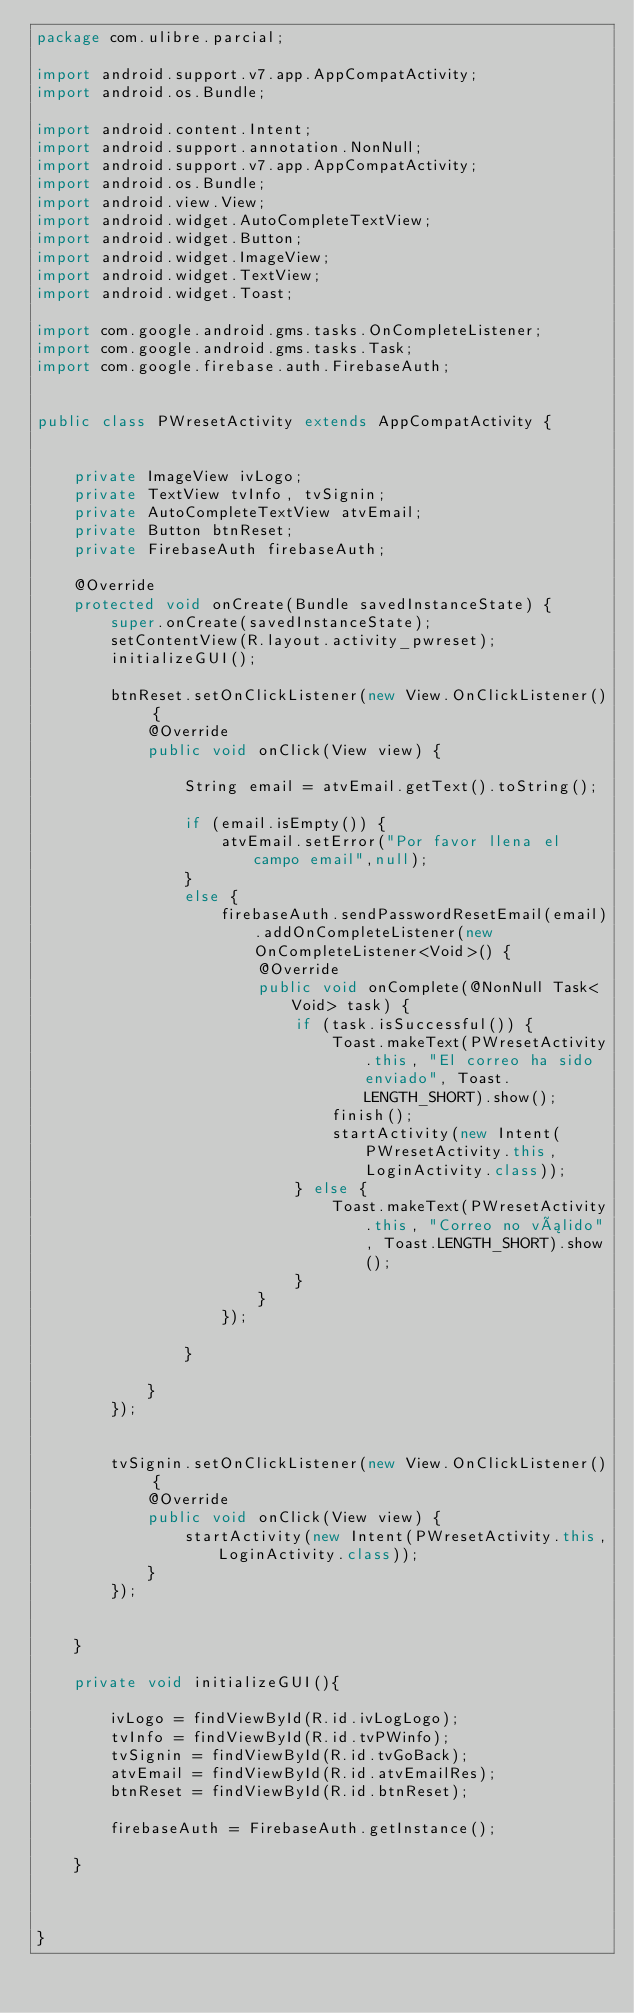<code> <loc_0><loc_0><loc_500><loc_500><_Java_>package com.ulibre.parcial;

import android.support.v7.app.AppCompatActivity;
import android.os.Bundle;

import android.content.Intent;
import android.support.annotation.NonNull;
import android.support.v7.app.AppCompatActivity;
import android.os.Bundle;
import android.view.View;
import android.widget.AutoCompleteTextView;
import android.widget.Button;
import android.widget.ImageView;
import android.widget.TextView;
import android.widget.Toast;

import com.google.android.gms.tasks.OnCompleteListener;
import com.google.android.gms.tasks.Task;
import com.google.firebase.auth.FirebaseAuth;


public class PWresetActivity extends AppCompatActivity {


    private ImageView ivLogo;
    private TextView tvInfo, tvSignin;
    private AutoCompleteTextView atvEmail;
    private Button btnReset;
    private FirebaseAuth firebaseAuth;

    @Override
    protected void onCreate(Bundle savedInstanceState) {
        super.onCreate(savedInstanceState);
        setContentView(R.layout.activity_pwreset);
        initializeGUI();

        btnReset.setOnClickListener(new View.OnClickListener() {
            @Override
            public void onClick(View view) {

                String email = atvEmail.getText().toString();

                if (email.isEmpty()) {
                    atvEmail.setError("Por favor llena el campo email",null);
                }
                else {
                    firebaseAuth.sendPasswordResetEmail(email).addOnCompleteListener(new OnCompleteListener<Void>() {
                        @Override
                        public void onComplete(@NonNull Task<Void> task) {
                            if (task.isSuccessful()) {
                                Toast.makeText(PWresetActivity.this, "El correo ha sido enviado", Toast.LENGTH_SHORT).show();
                                finish();
                                startActivity(new Intent(PWresetActivity.this, LoginActivity.class));
                            } else {
                                Toast.makeText(PWresetActivity.this, "Correo no válido", Toast.LENGTH_SHORT).show();
                            }
                        }
                    });

                }

            }
        });


        tvSignin.setOnClickListener(new View.OnClickListener() {
            @Override
            public void onClick(View view) {
                startActivity(new Intent(PWresetActivity.this,LoginActivity.class));
            }
        });


    }

    private void initializeGUI(){

        ivLogo = findViewById(R.id.ivLogLogo);
        tvInfo = findViewById(R.id.tvPWinfo);
        tvSignin = findViewById(R.id.tvGoBack);
        atvEmail = findViewById(R.id.atvEmailRes);
        btnReset = findViewById(R.id.btnReset);

        firebaseAuth = FirebaseAuth.getInstance();

    }



}
</code> 